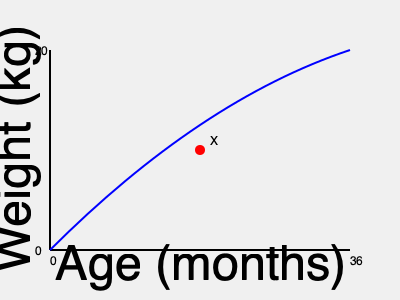As a nurse, you're reviewing a growth chart for a 24-month-old boy. The red dot (X) on the chart represents the child's current weight. Based on this information, what would be your assessment of the child's growth status? To interpret this growth chart accurately, we need to follow these steps:

1. Identify the axes: The x-axis represents age in months (0-36), and the y-axis represents weight in kilograms (0-20).

2. Locate the patient's data point: The red dot (X) represents the child's current weight at 24 months of age.

3. Understand the growth curve: The blue line represents the 50th percentile growth curve for boys.

4. Compare the patient's data to the growth curve:
   - The red dot is slightly below the 50th percentile line.
   - This indicates that the child's weight is just below average for his age.

5. Assess the growth status:
   - Being slightly below the 50th percentile is still within the normal range.
   - There are no signs of severe underweight or failure to thrive.
   - The child's growth appears to be following a consistent pattern.

6. Consider the implications:
   - This weight is generally considered healthy for a 24-month-old boy.
   - No immediate intervention is necessary, but continued monitoring is important.

7. Next steps:
   - Continue regular check-ups to ensure the child maintains a consistent growth pattern.
   - Provide age-appropriate nutritional advice to support optimal growth.

Based on this analysis, the child's growth status can be described as normal, with weight slightly below average but within an acceptable range.
Answer: Normal growth; weight slightly below average but within acceptable range. 